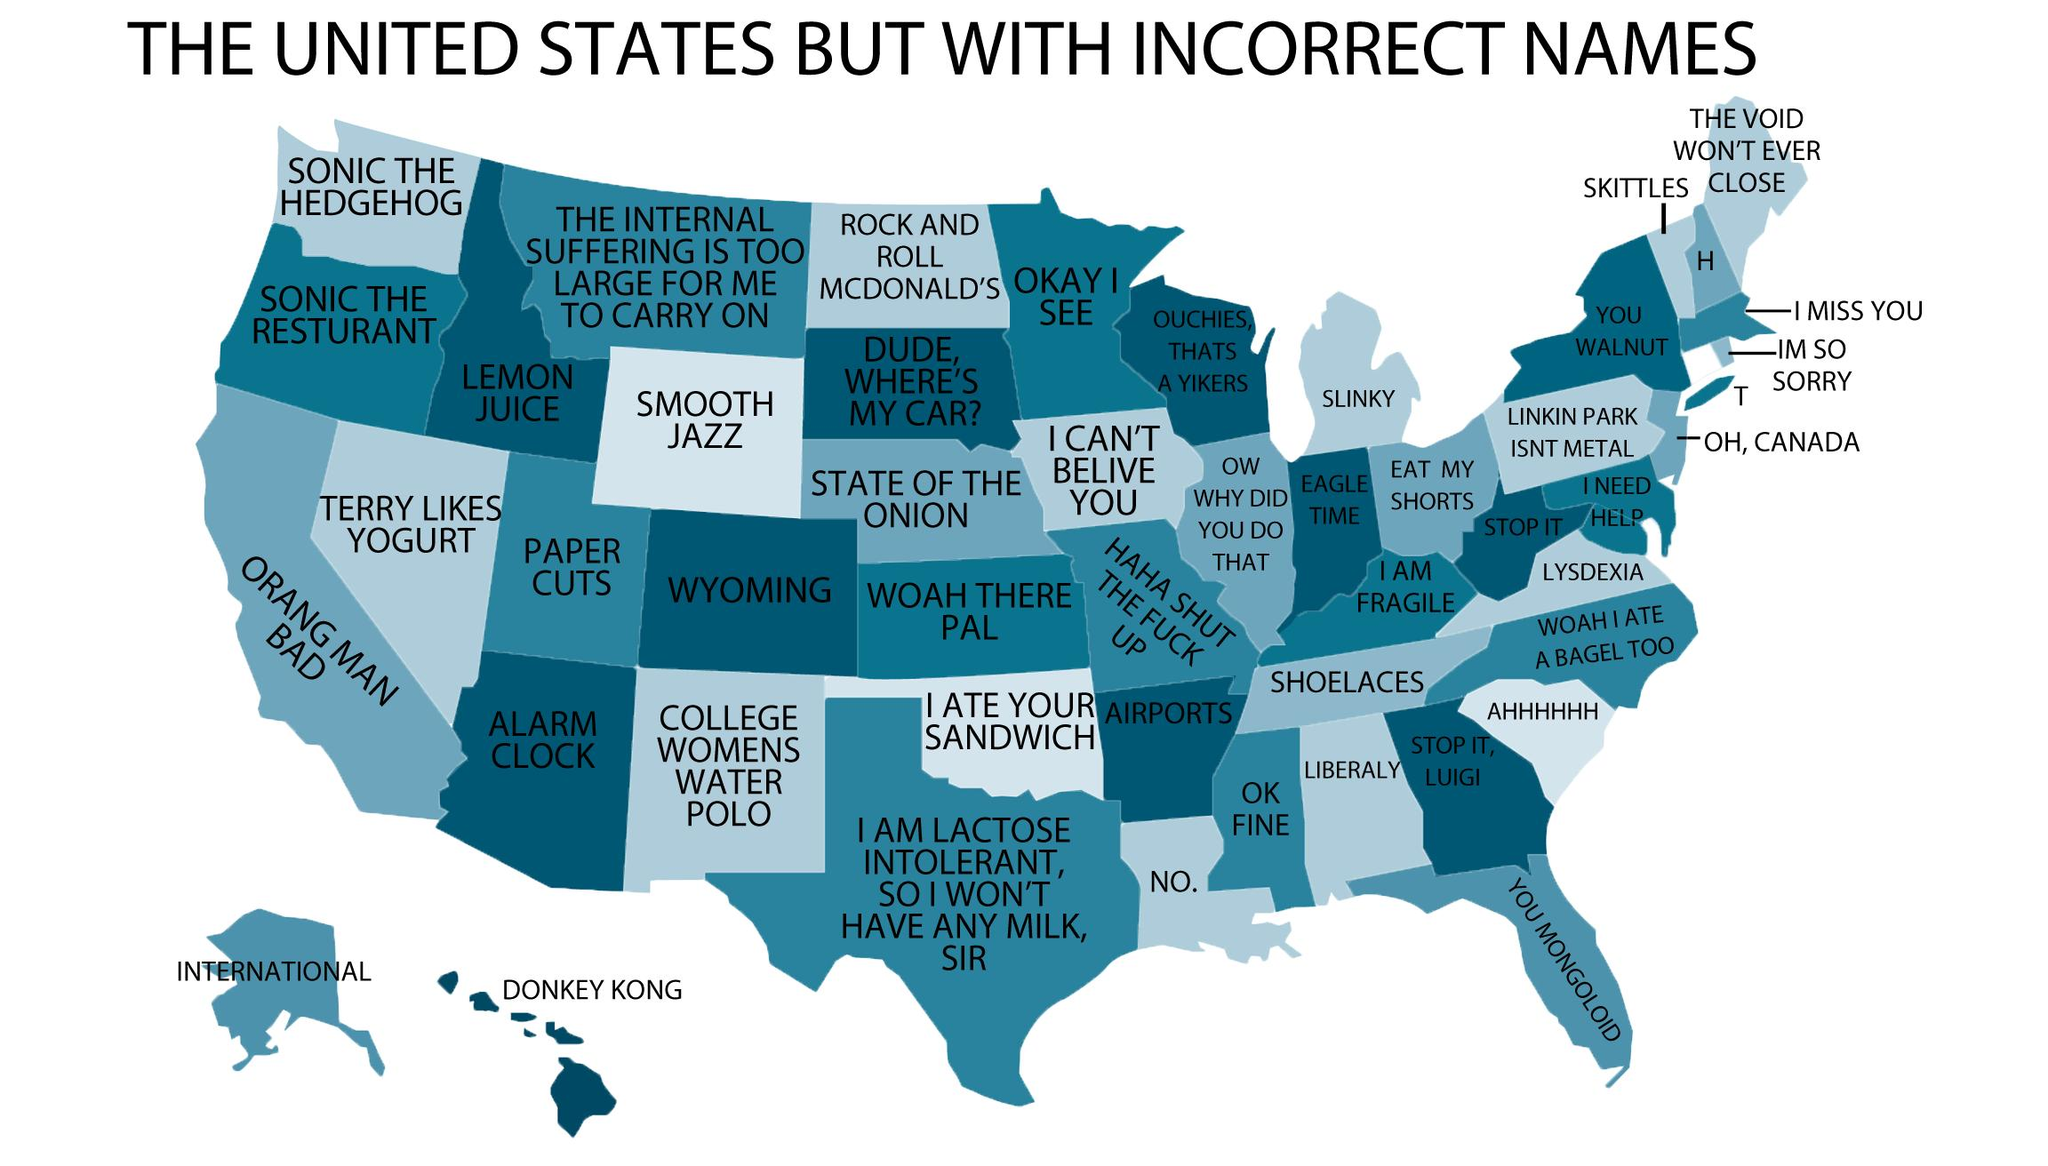Identify some key points in this picture. There are 49 states with incorrect names on the map. Wyoming is the only state whose name is spelled correctly. 